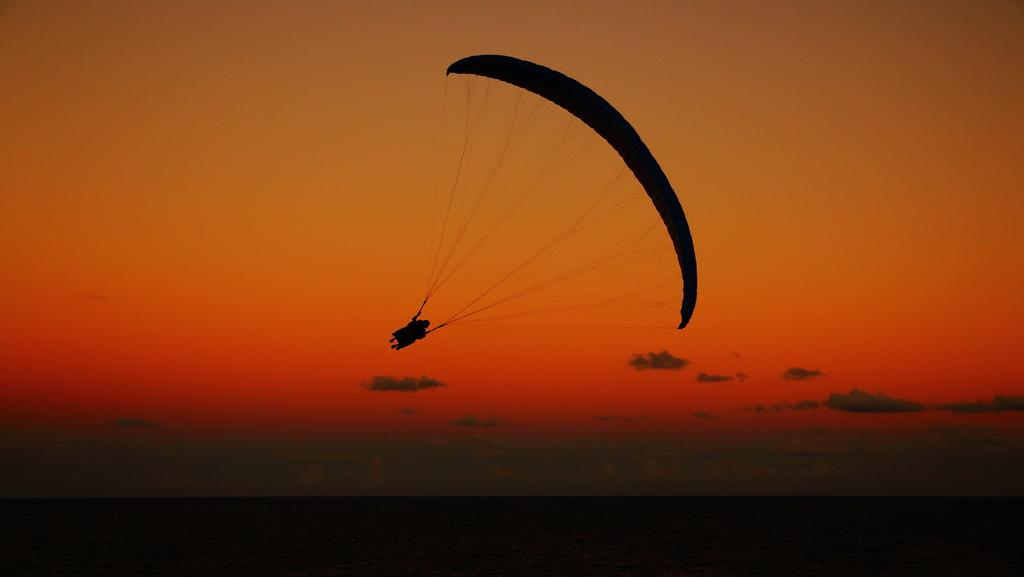What activity is the person in the image engaged in? The person in the image is parasailing. What time of day was the image taken? The image was taken at dawn. What can be seen in the background of the image? The sky is visible in the image. Are there any weather conditions visible in the image? Yes, clouds are present in the sky. What type of toad can be seen jumping in the image? There is no toad present in the image; it features a person parasailing. What part of the person's flesh can be seen in the image? There is no visible flesh in the image, as the person is wearing a harness and a helmet while parasailing. 